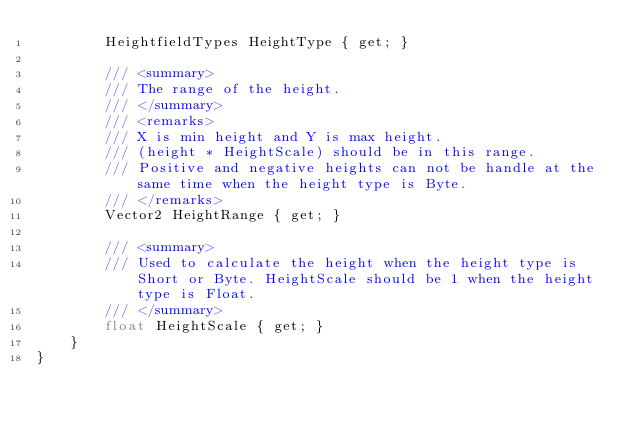<code> <loc_0><loc_0><loc_500><loc_500><_C#_>        HeightfieldTypes HeightType { get; }

        /// <summary>
        /// The range of the height.
        /// </summary>
        /// <remarks>
        /// X is min height and Y is max height.
        /// (height * HeightScale) should be in this range.
        /// Positive and negative heights can not be handle at the same time when the height type is Byte.
        /// </remarks>
        Vector2 HeightRange { get; }

        /// <summary>
        /// Used to calculate the height when the height type is Short or Byte. HeightScale should be 1 when the height type is Float.
        /// </summary>
        float HeightScale { get; }
    }
}
</code> 